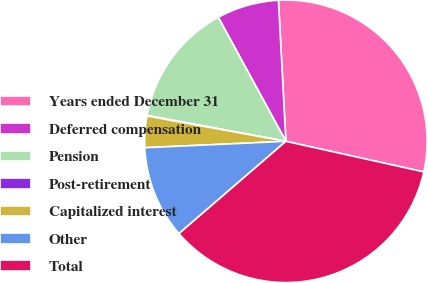<chart> <loc_0><loc_0><loc_500><loc_500><pie_chart><fcel>Years ended December 31<fcel>Deferred compensation<fcel>Pension<fcel>Post-retirement<fcel>Capitalized interest<fcel>Other<fcel>Total<nl><fcel>29.32%<fcel>7.1%<fcel>14.12%<fcel>0.07%<fcel>3.59%<fcel>10.61%<fcel>35.2%<nl></chart> 